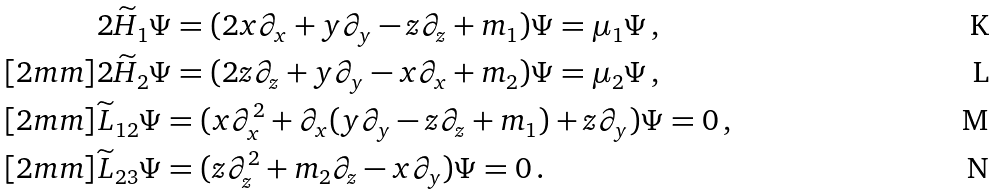Convert formula to latex. <formula><loc_0><loc_0><loc_500><loc_500>& 2 \widetilde { H } _ { 1 } \Psi = ( 2 x \partial _ { x } + y \partial _ { y } - z \partial _ { z } + m _ { 1 } ) \Psi = \mu _ { 1 } \Psi \, , \\ [ 2 m m ] & 2 \widetilde { H } _ { 2 } \Psi = ( 2 z \partial _ { z } + y \partial _ { y } - x \partial _ { x } + m _ { 2 } ) \Psi = \mu _ { 2 } \Psi \, , \\ [ 2 m m ] & \widetilde { L } _ { 1 2 } \Psi = ( x \partial _ { x } ^ { 2 } + \partial _ { x } ( y \partial _ { y } - z \partial _ { z } + m _ { 1 } ) + z \partial _ { y } ) \Psi = 0 \, , \\ [ 2 m m ] & \widetilde { L } _ { 2 3 } \Psi = ( z \partial _ { z } ^ { 2 } + m _ { 2 } \partial _ { z } - x \partial _ { y } ) \Psi = 0 \, .</formula> 